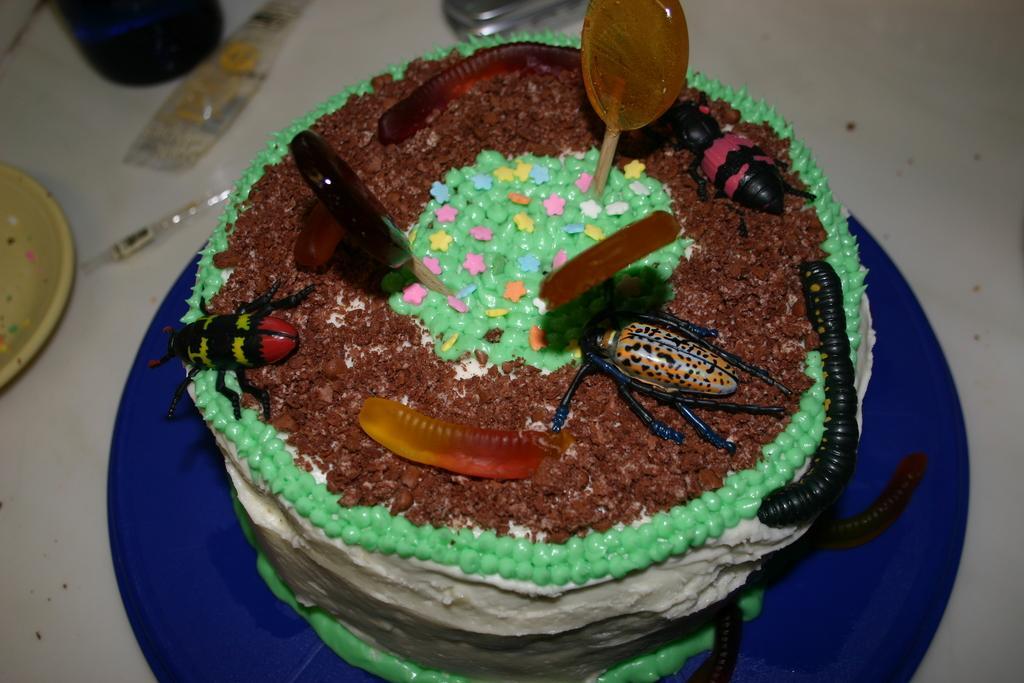Could you give a brief overview of what you see in this image? In this image I can see the white colored surface and on it I can see a blue colored plate. On the plate I can see a cake which is brown, green, blue, yellow, red, pink, white and black in color. I can see few other objects on the white colored surface. 